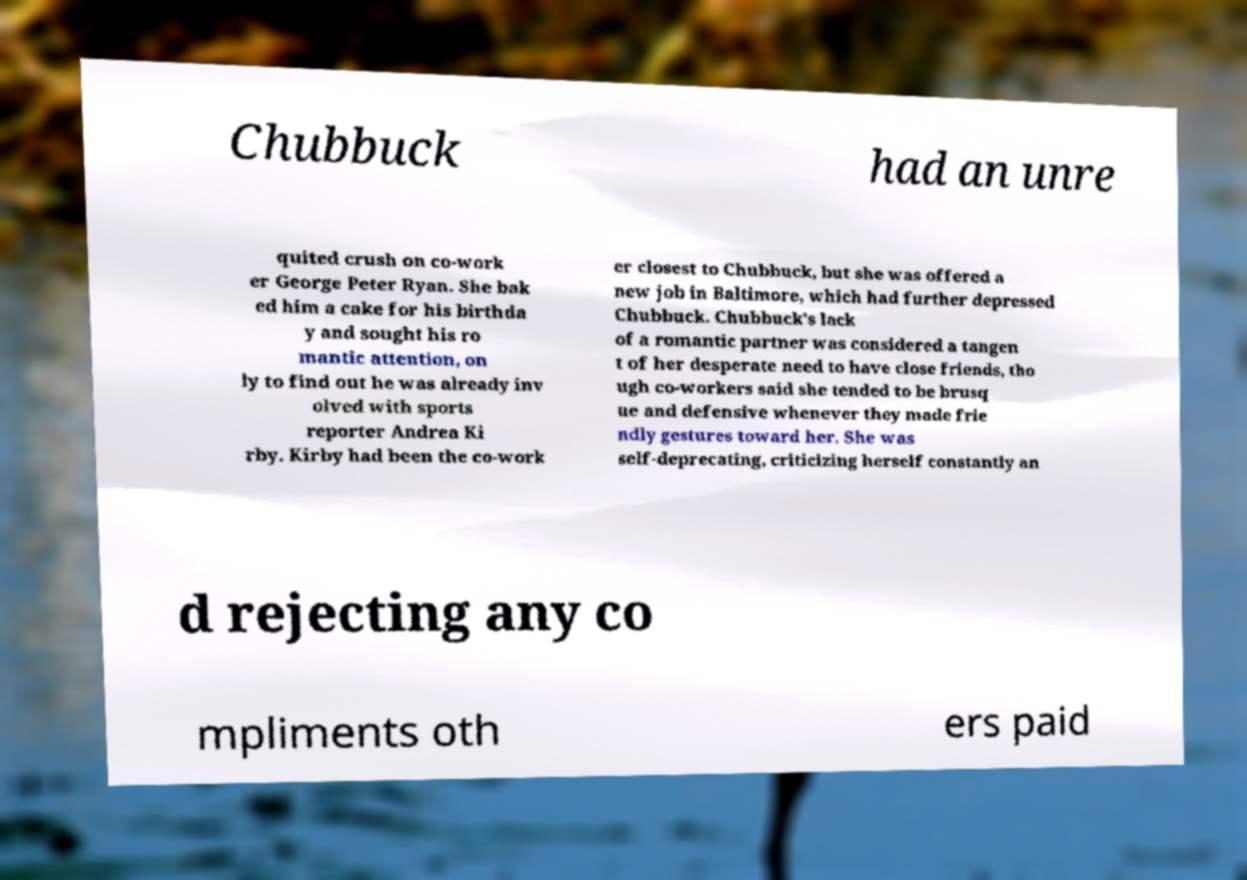I need the written content from this picture converted into text. Can you do that? Chubbuck had an unre quited crush on co-work er George Peter Ryan. She bak ed him a cake for his birthda y and sought his ro mantic attention, on ly to find out he was already inv olved with sports reporter Andrea Ki rby. Kirby had been the co-work er closest to Chubbuck, but she was offered a new job in Baltimore, which had further depressed Chubbuck. Chubbuck's lack of a romantic partner was considered a tangen t of her desperate need to have close friends, tho ugh co-workers said she tended to be brusq ue and defensive whenever they made frie ndly gestures toward her. She was self-deprecating, criticizing herself constantly an d rejecting any co mpliments oth ers paid 